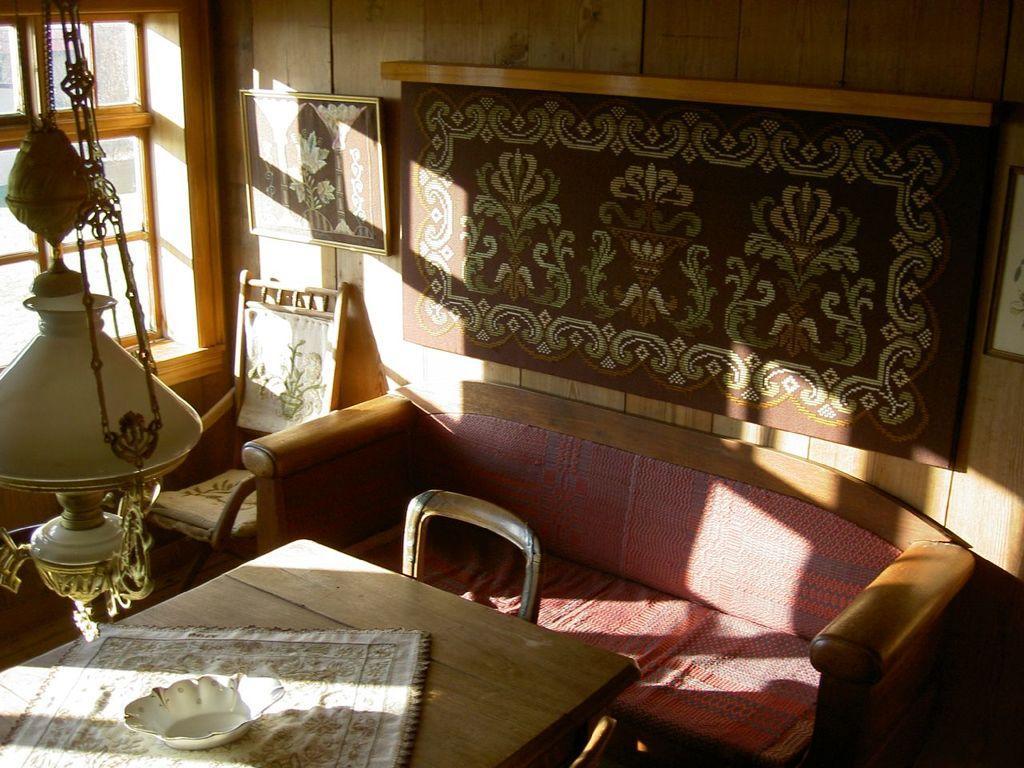In one or two sentences, can you explain what this image depicts? Its a room, there is a sofa and in front of the sofa there is a table and above the table there is a bowl and below the bowl there is a cloth. Above the table there is a board to the left side of the board there is a portrait, behind the portrait there is a wooden wall and below the portrait there is a chair, to the left side of the chair there is a window, there is a lot of sunlight inside the room and also there is a hanging above the table. 